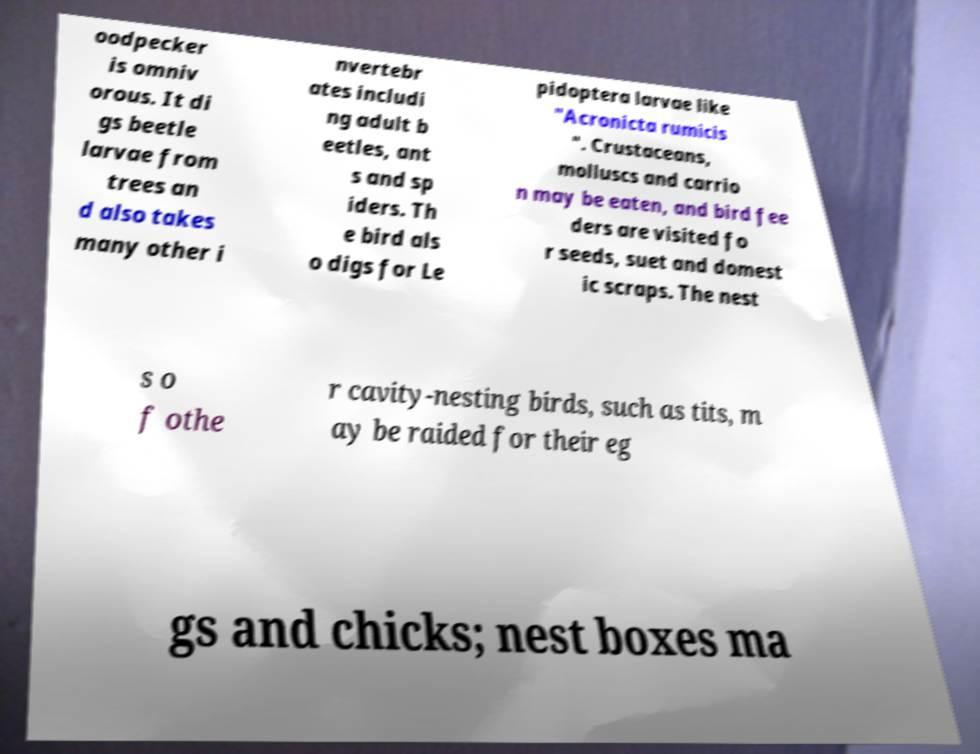Could you extract and type out the text from this image? oodpecker is omniv orous. It di gs beetle larvae from trees an d also takes many other i nvertebr ates includi ng adult b eetles, ant s and sp iders. Th e bird als o digs for Le pidoptera larvae like "Acronicta rumicis ". Crustaceans, molluscs and carrio n may be eaten, and bird fee ders are visited fo r seeds, suet and domest ic scraps. The nest s o f othe r cavity-nesting birds, such as tits, m ay be raided for their eg gs and chicks; nest boxes ma 